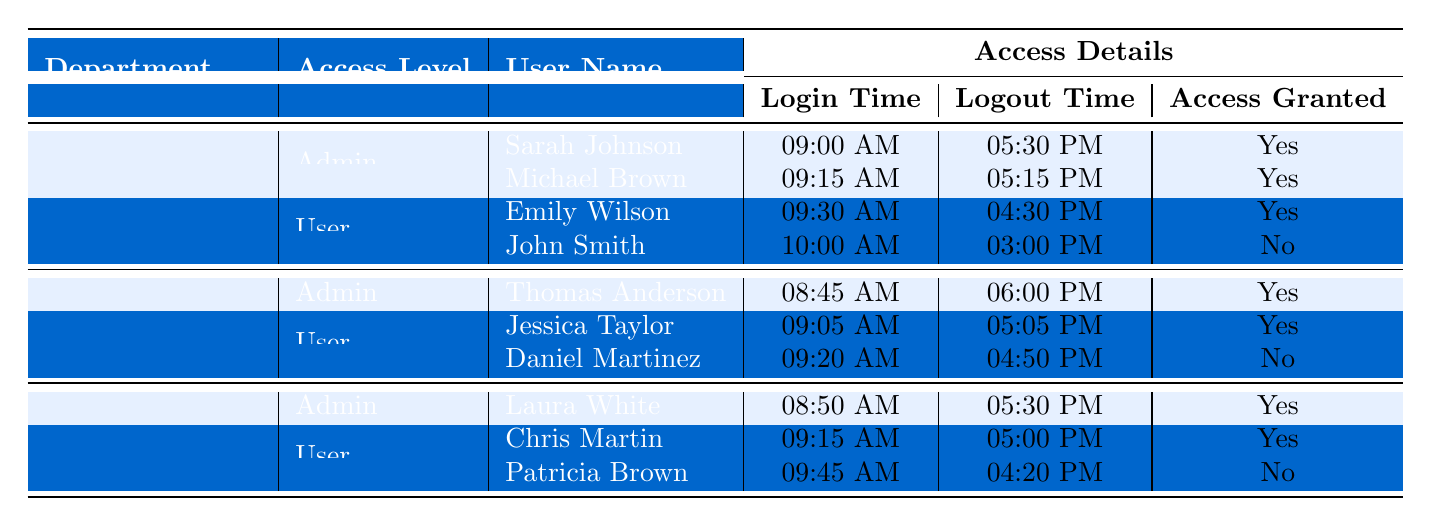What are the access levels available in the Human Resources department? The table lists the "Access Level" under the Human Resources department, which includes "Admin" and "User".
Answer: Admin, User How many users in the IT Support department had their access granted? In the IT Support department, Thomas Anderson (Admin) and Jessica Taylor (User) had their access granted, totaling 2 users.
Answer: 2 Was John Smith granted access? John Smith's "Access Granted" status is marked as "No" in the table, indicating he was not granted access.
Answer: No Which user logged in the earliest in the Sales department? By comparing the "Login Time" of users in the Sales department, Laura White logged in at 08:50 AM, which is earlier than others.
Answer: Laura White How many users in total had their access granted across all departments? Counting the users with "Access Granted" marked as Yes, we have Sarah Johnson, Michael Brown, Emily Wilson, Thomas Anderson, Jessica Taylor, Laura White, and Chris Martin, totaling 6 users.
Answer: 6 What is the difference in logout times between the earliest and latest logout in the Human Resources department? The earliest logout time in Human Resources is John Smith at 03:00 PM, and the latest is Sarah Johnson at 05:30 PM. The difference is 2 hours and 30 minutes.
Answer: 2 hours 30 minutes Which department has a user with denied access? By reviewing the table, both the Human Resources and IT Support departments have users (John Smith and Daniel Martinez) marked as not granted access.
Answer: Human Resources, IT Support If we consider all departments, how many total access levels are represented? Each department has 2 access levels (Admin and User), with 3 departments: (2 levels x 3 departments) = 6 total access levels represented.
Answer: 6 What is the ratio of granted access users to denied access users in the IT Support department? In IT Support, there are 2 granted access users (Thomas Anderson, Jessica Taylor) and 1 denied access user (Daniel Martinez), giving a ratio of 2:1.
Answer: 2:1 Is there a user named "Daniel Martinez" mentioned in the table? Yes, Daniel Martinez is listed under the IT Support department with the status of not granted access.
Answer: Yes What is the total number of users across all departments? Counting the users in each department, there are 8 users in total across Human Resources (4), IT Support (3), and Sales (3) departments, totaling to 10.
Answer: 10 